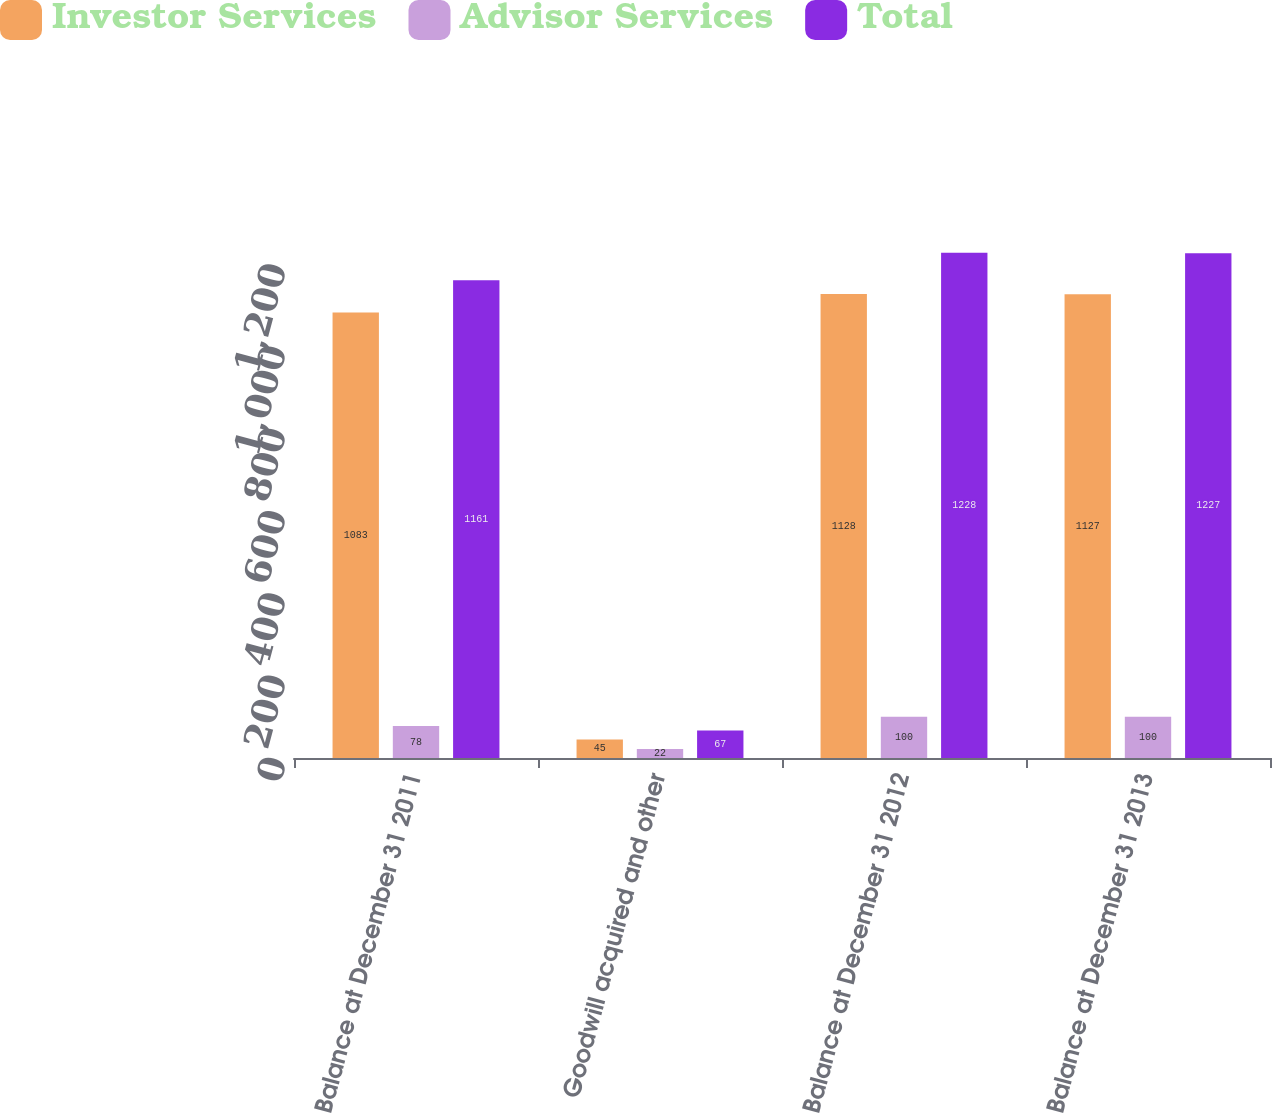Convert chart. <chart><loc_0><loc_0><loc_500><loc_500><stacked_bar_chart><ecel><fcel>Balance at December 31 2011<fcel>Goodwill acquired and other<fcel>Balance at December 31 2012<fcel>Balance at December 31 2013<nl><fcel>Investor Services<fcel>1083<fcel>45<fcel>1128<fcel>1127<nl><fcel>Advisor Services<fcel>78<fcel>22<fcel>100<fcel>100<nl><fcel>Total<fcel>1161<fcel>67<fcel>1228<fcel>1227<nl></chart> 